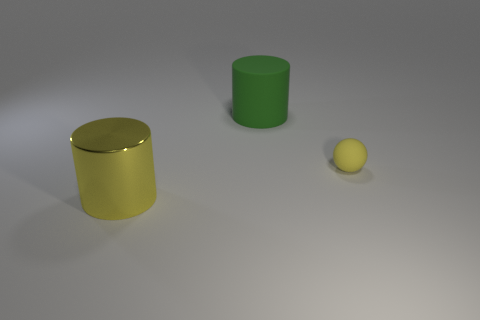There is a thing in front of the yellow matte thing; what is its size?
Provide a succinct answer. Large. Is the number of large cylinders that are in front of the large metal thing the same as the number of green things that are right of the yellow sphere?
Your answer should be compact. Yes. The large thing left of the cylinder that is behind the rubber thing that is to the right of the large green cylinder is what color?
Provide a short and direct response. Yellow. What number of things are behind the big yellow metal object and on the left side of the small yellow rubber object?
Keep it short and to the point. 1. There is a object that is behind the yellow ball; is its color the same as the object that is in front of the tiny yellow thing?
Provide a succinct answer. No. Is there anything else that is the same material as the tiny thing?
Provide a short and direct response. Yes. What is the size of the rubber object that is the same shape as the yellow metal thing?
Provide a succinct answer. Large. Are there any big yellow shiny objects behind the matte ball?
Make the answer very short. No. Are there an equal number of big rubber cylinders that are in front of the metal thing and cylinders?
Your answer should be compact. No. Are there any yellow rubber things behind the large object behind the rubber object that is in front of the big green matte object?
Offer a very short reply. No. 